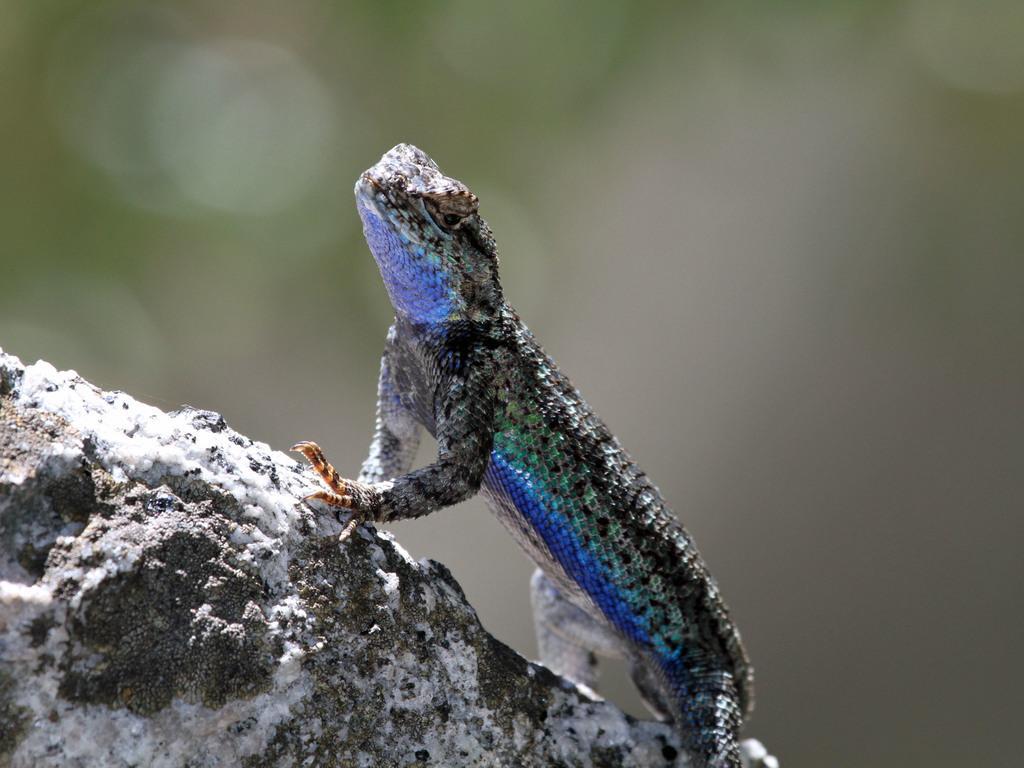Could you give a brief overview of what you see in this image? In this image we can see a lizard on a stone. In the background the image is blur. 